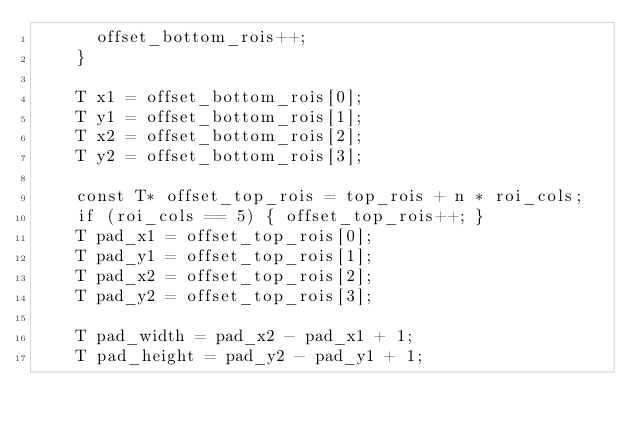Convert code to text. <code><loc_0><loc_0><loc_500><loc_500><_Cuda_>      offset_bottom_rois++;
    }

    T x1 = offset_bottom_rois[0]; 
    T y1 = offset_bottom_rois[1];
    T x2 = offset_bottom_rois[2];
    T y2 = offset_bottom_rois[3];

    const T* offset_top_rois = top_rois + n * roi_cols;
    if (roi_cols == 5) { offset_top_rois++; }
    T pad_x1 = offset_top_rois[0];
    T pad_y1 = offset_top_rois[1];
    T pad_x2 = offset_top_rois[2];
    T pad_y2 = offset_top_rois[3];

    T pad_width = pad_x2 - pad_x1 + 1;
    T pad_height = pad_y2 - pad_y1 + 1;
</code> 